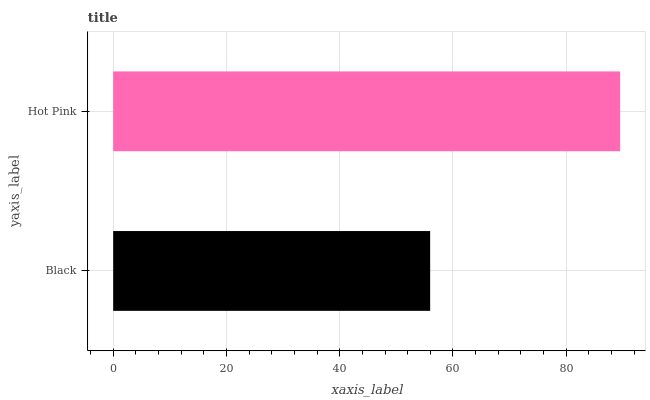Is Black the minimum?
Answer yes or no. Yes. Is Hot Pink the maximum?
Answer yes or no. Yes. Is Hot Pink the minimum?
Answer yes or no. No. Is Hot Pink greater than Black?
Answer yes or no. Yes. Is Black less than Hot Pink?
Answer yes or no. Yes. Is Black greater than Hot Pink?
Answer yes or no. No. Is Hot Pink less than Black?
Answer yes or no. No. Is Hot Pink the high median?
Answer yes or no. Yes. Is Black the low median?
Answer yes or no. Yes. Is Black the high median?
Answer yes or no. No. Is Hot Pink the low median?
Answer yes or no. No. 